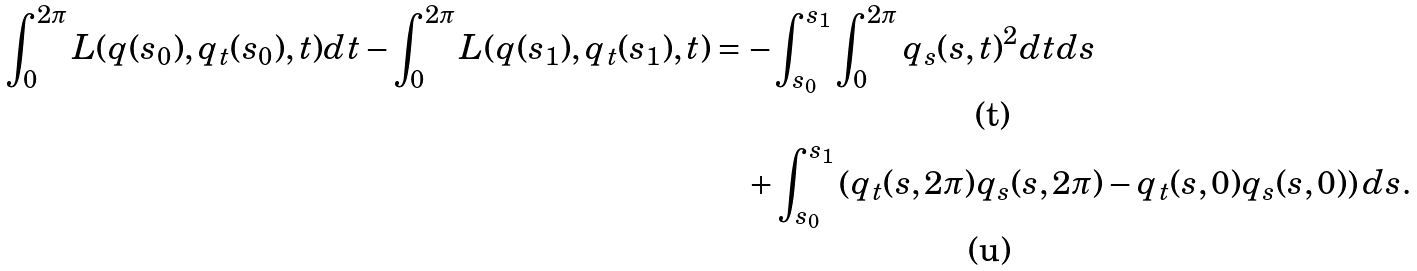<formula> <loc_0><loc_0><loc_500><loc_500>\int _ { 0 } ^ { 2 \pi } L ( q ( s _ { 0 } ) , q _ { t } ( s _ { 0 } ) , t ) d t - \int _ { 0 } ^ { 2 \pi } L ( q ( s _ { 1 } ) , q _ { t } ( s _ { 1 } ) , t ) & = - \int _ { s _ { 0 } } ^ { s _ { 1 } } \int _ { 0 } ^ { 2 \pi } q _ { s } ( s , t ) ^ { 2 } d t d s \\ & \quad + \int _ { s _ { 0 } } ^ { s _ { 1 } } \left ( q _ { t } ( s , 2 \pi ) q _ { s } ( s , 2 \pi ) - q _ { t } ( s , 0 ) q _ { s } ( s , 0 ) \right ) d s .</formula> 